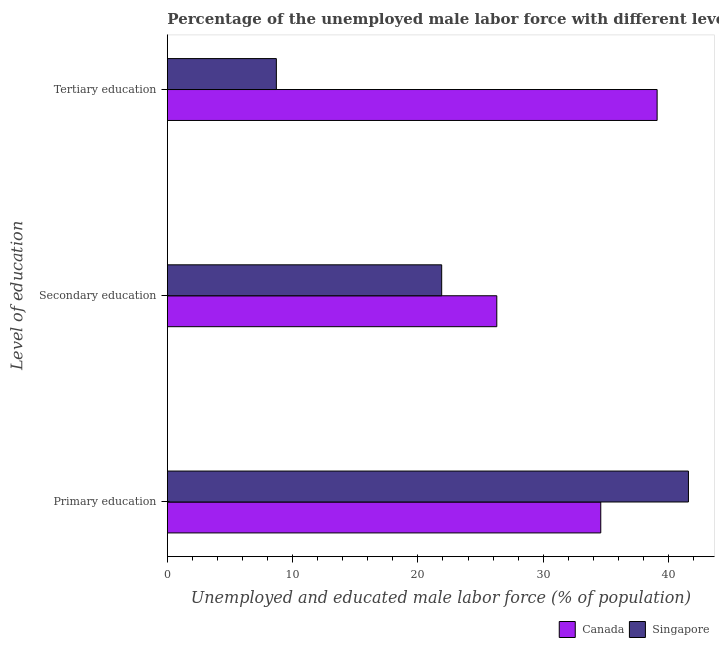Are the number of bars per tick equal to the number of legend labels?
Provide a succinct answer. Yes. How many bars are there on the 1st tick from the top?
Offer a very short reply. 2. How many bars are there on the 2nd tick from the bottom?
Provide a short and direct response. 2. What is the label of the 1st group of bars from the top?
Give a very brief answer. Tertiary education. What is the percentage of male labor force who received primary education in Canada?
Your response must be concise. 34.6. Across all countries, what is the maximum percentage of male labor force who received secondary education?
Provide a short and direct response. 26.3. Across all countries, what is the minimum percentage of male labor force who received tertiary education?
Provide a succinct answer. 8.7. In which country was the percentage of male labor force who received tertiary education maximum?
Offer a terse response. Canada. In which country was the percentage of male labor force who received tertiary education minimum?
Provide a succinct answer. Singapore. What is the total percentage of male labor force who received tertiary education in the graph?
Keep it short and to the point. 47.8. What is the difference between the percentage of male labor force who received tertiary education in Singapore and the percentage of male labor force who received primary education in Canada?
Your answer should be compact. -25.9. What is the average percentage of male labor force who received primary education per country?
Ensure brevity in your answer.  38.1. What is the difference between the percentage of male labor force who received primary education and percentage of male labor force who received secondary education in Singapore?
Give a very brief answer. 19.7. In how many countries, is the percentage of male labor force who received tertiary education greater than 16 %?
Make the answer very short. 1. What is the ratio of the percentage of male labor force who received tertiary education in Canada to that in Singapore?
Your response must be concise. 4.49. What is the difference between the highest and the second highest percentage of male labor force who received primary education?
Offer a very short reply. 7. What is the difference between the highest and the lowest percentage of male labor force who received secondary education?
Your answer should be compact. 4.4. In how many countries, is the percentage of male labor force who received secondary education greater than the average percentage of male labor force who received secondary education taken over all countries?
Your answer should be very brief. 1. What does the 2nd bar from the top in Primary education represents?
Give a very brief answer. Canada. How many bars are there?
Provide a succinct answer. 6. Are the values on the major ticks of X-axis written in scientific E-notation?
Offer a very short reply. No. Does the graph contain grids?
Keep it short and to the point. No. How many legend labels are there?
Offer a very short reply. 2. What is the title of the graph?
Offer a very short reply. Percentage of the unemployed male labor force with different levels of education in countries. Does "Croatia" appear as one of the legend labels in the graph?
Your answer should be compact. No. What is the label or title of the X-axis?
Ensure brevity in your answer.  Unemployed and educated male labor force (% of population). What is the label or title of the Y-axis?
Provide a short and direct response. Level of education. What is the Unemployed and educated male labor force (% of population) of Canada in Primary education?
Offer a very short reply. 34.6. What is the Unemployed and educated male labor force (% of population) in Singapore in Primary education?
Your answer should be very brief. 41.6. What is the Unemployed and educated male labor force (% of population) in Canada in Secondary education?
Give a very brief answer. 26.3. What is the Unemployed and educated male labor force (% of population) in Singapore in Secondary education?
Your response must be concise. 21.9. What is the Unemployed and educated male labor force (% of population) in Canada in Tertiary education?
Your response must be concise. 39.1. What is the Unemployed and educated male labor force (% of population) in Singapore in Tertiary education?
Offer a very short reply. 8.7. Across all Level of education, what is the maximum Unemployed and educated male labor force (% of population) in Canada?
Provide a short and direct response. 39.1. Across all Level of education, what is the maximum Unemployed and educated male labor force (% of population) of Singapore?
Provide a succinct answer. 41.6. Across all Level of education, what is the minimum Unemployed and educated male labor force (% of population) of Canada?
Your answer should be compact. 26.3. Across all Level of education, what is the minimum Unemployed and educated male labor force (% of population) of Singapore?
Keep it short and to the point. 8.7. What is the total Unemployed and educated male labor force (% of population) of Singapore in the graph?
Your answer should be very brief. 72.2. What is the difference between the Unemployed and educated male labor force (% of population) in Singapore in Primary education and that in Secondary education?
Give a very brief answer. 19.7. What is the difference between the Unemployed and educated male labor force (% of population) in Singapore in Primary education and that in Tertiary education?
Make the answer very short. 32.9. What is the difference between the Unemployed and educated male labor force (% of population) of Canada in Secondary education and that in Tertiary education?
Offer a terse response. -12.8. What is the difference between the Unemployed and educated male labor force (% of population) of Canada in Primary education and the Unemployed and educated male labor force (% of population) of Singapore in Tertiary education?
Provide a short and direct response. 25.9. What is the average Unemployed and educated male labor force (% of population) in Canada per Level of education?
Provide a succinct answer. 33.33. What is the average Unemployed and educated male labor force (% of population) of Singapore per Level of education?
Your response must be concise. 24.07. What is the difference between the Unemployed and educated male labor force (% of population) of Canada and Unemployed and educated male labor force (% of population) of Singapore in Tertiary education?
Your response must be concise. 30.4. What is the ratio of the Unemployed and educated male labor force (% of population) of Canada in Primary education to that in Secondary education?
Your response must be concise. 1.32. What is the ratio of the Unemployed and educated male labor force (% of population) of Singapore in Primary education to that in Secondary education?
Make the answer very short. 1.9. What is the ratio of the Unemployed and educated male labor force (% of population) in Canada in Primary education to that in Tertiary education?
Give a very brief answer. 0.88. What is the ratio of the Unemployed and educated male labor force (% of population) of Singapore in Primary education to that in Tertiary education?
Give a very brief answer. 4.78. What is the ratio of the Unemployed and educated male labor force (% of population) of Canada in Secondary education to that in Tertiary education?
Offer a very short reply. 0.67. What is the ratio of the Unemployed and educated male labor force (% of population) in Singapore in Secondary education to that in Tertiary education?
Offer a very short reply. 2.52. What is the difference between the highest and the second highest Unemployed and educated male labor force (% of population) in Canada?
Your answer should be very brief. 4.5. What is the difference between the highest and the lowest Unemployed and educated male labor force (% of population) in Canada?
Make the answer very short. 12.8. What is the difference between the highest and the lowest Unemployed and educated male labor force (% of population) of Singapore?
Provide a succinct answer. 32.9. 